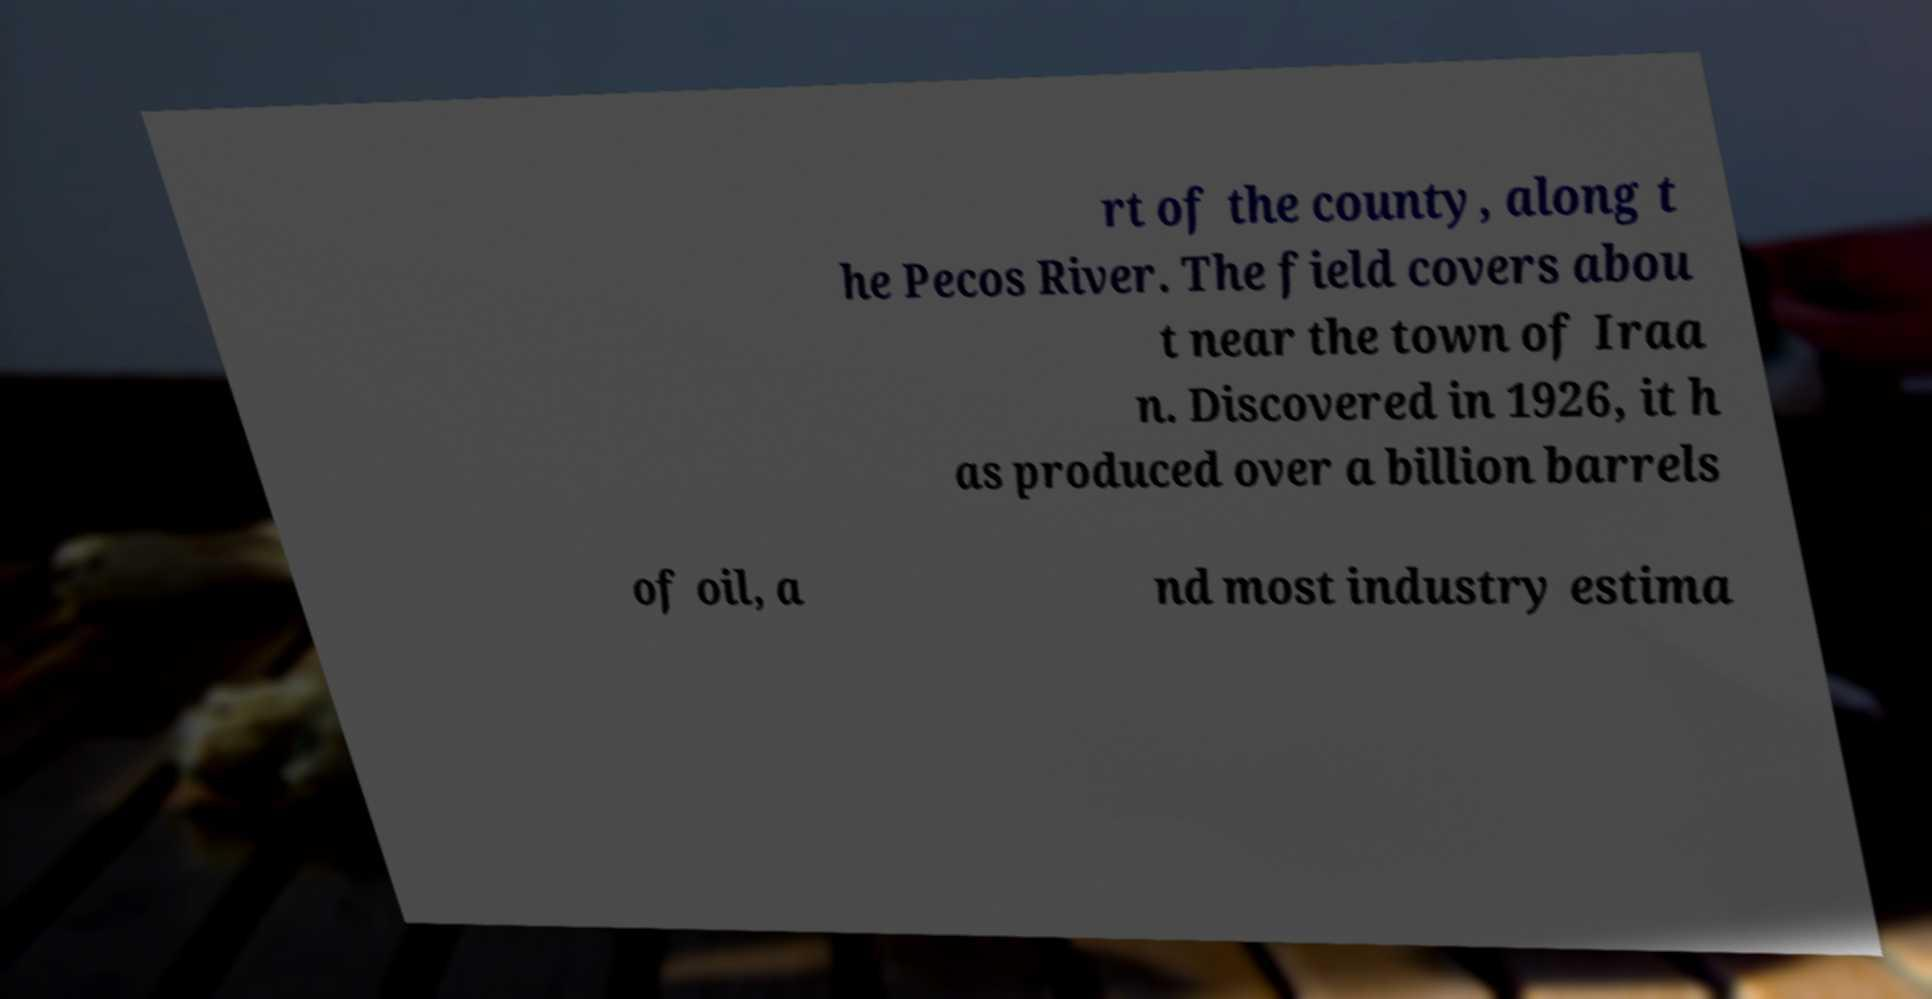Please read and relay the text visible in this image. What does it say? rt of the county, along t he Pecos River. The field covers abou t near the town of Iraa n. Discovered in 1926, it h as produced over a billion barrels of oil, a nd most industry estima 